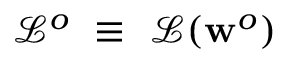<formula> <loc_0><loc_0><loc_500><loc_500>\mathcal { L } ^ { o } \equiv \mathcal { L } ( w ^ { o } )</formula> 